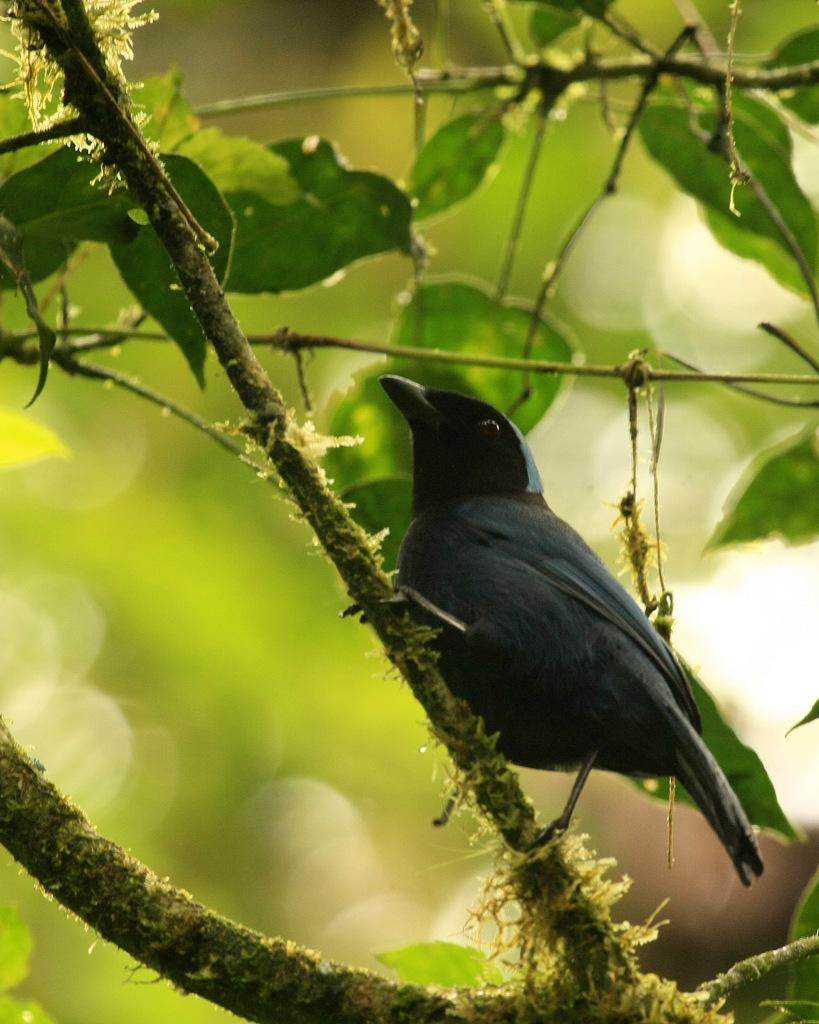What type of animal is present in the image? There is a bird in the image. What else can be seen in the image besides the bird? There are leaves in the image. Can you describe the background of the image? The background of the image is blurry. What time of day is depicted in the image? The time of day cannot be determined from the image, as there are no specific indicators of time. 